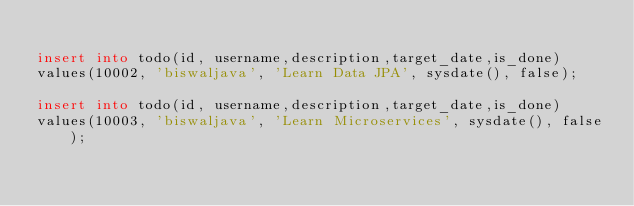Convert code to text. <code><loc_0><loc_0><loc_500><loc_500><_SQL_>
insert into todo(id, username,description,target_date,is_done)
values(10002, 'biswaljava', 'Learn Data JPA', sysdate(), false);

insert into todo(id, username,description,target_date,is_done)
values(10003, 'biswaljava', 'Learn Microservices', sysdate(), false);</code> 